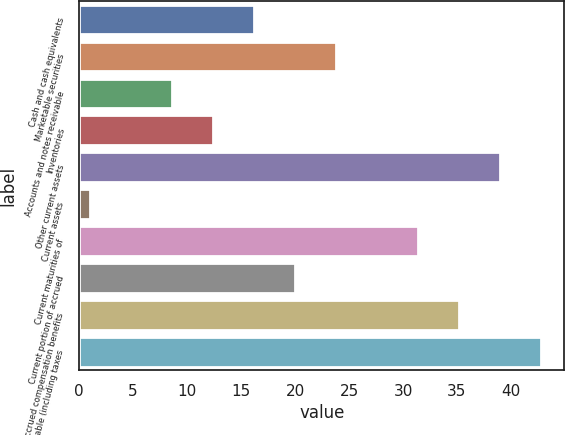<chart> <loc_0><loc_0><loc_500><loc_500><bar_chart><fcel>Cash and cash equivalents<fcel>Marketable securities<fcel>Accounts and notes receivable<fcel>Inventories<fcel>Other current assets<fcel>Current assets<fcel>Current maturities of<fcel>Current portion of accrued<fcel>Accrued compensation benefits<fcel>Taxes payable (including taxes<nl><fcel>16.2<fcel>23.8<fcel>8.6<fcel>12.4<fcel>39<fcel>1<fcel>31.4<fcel>20<fcel>35.2<fcel>42.8<nl></chart> 